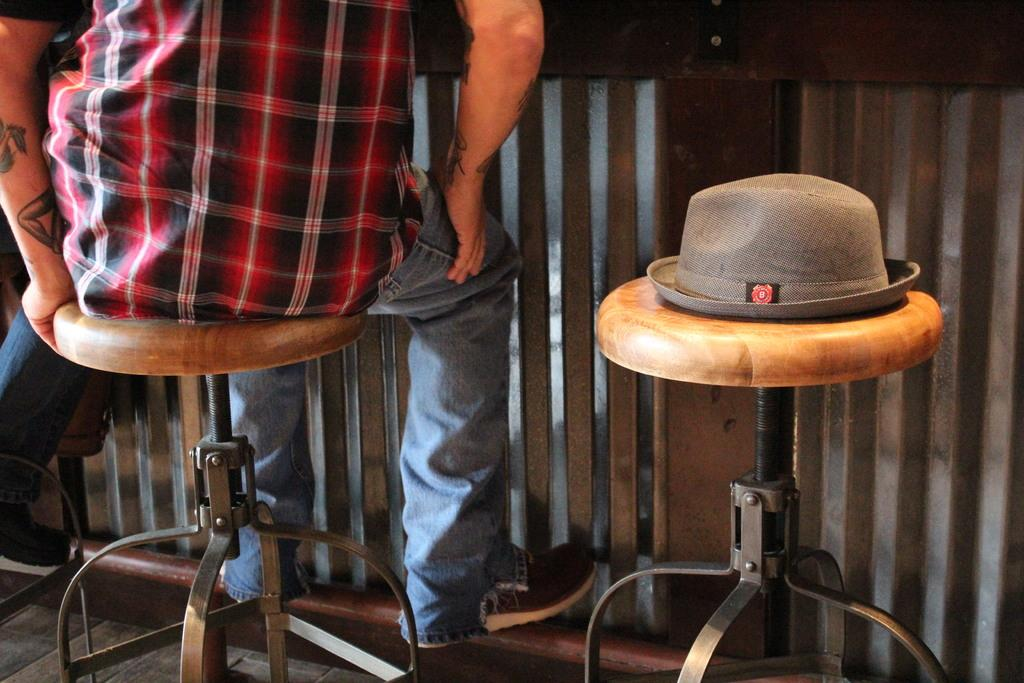Who is present in the image? There is a person in the image. What is the person wearing? The person is wearing a black and red shirt. What is the person's position in the image? The person is sitting on a stool. Are there any other stools visible in the image? Yes, there is another stool beside the person. What other accessory can be seen in the image? There is a hat in the image. What type of fowl is sitting on the stool next to the person in the image? There is no fowl present in the image; it only features a person sitting on a stool and another stool beside them. 